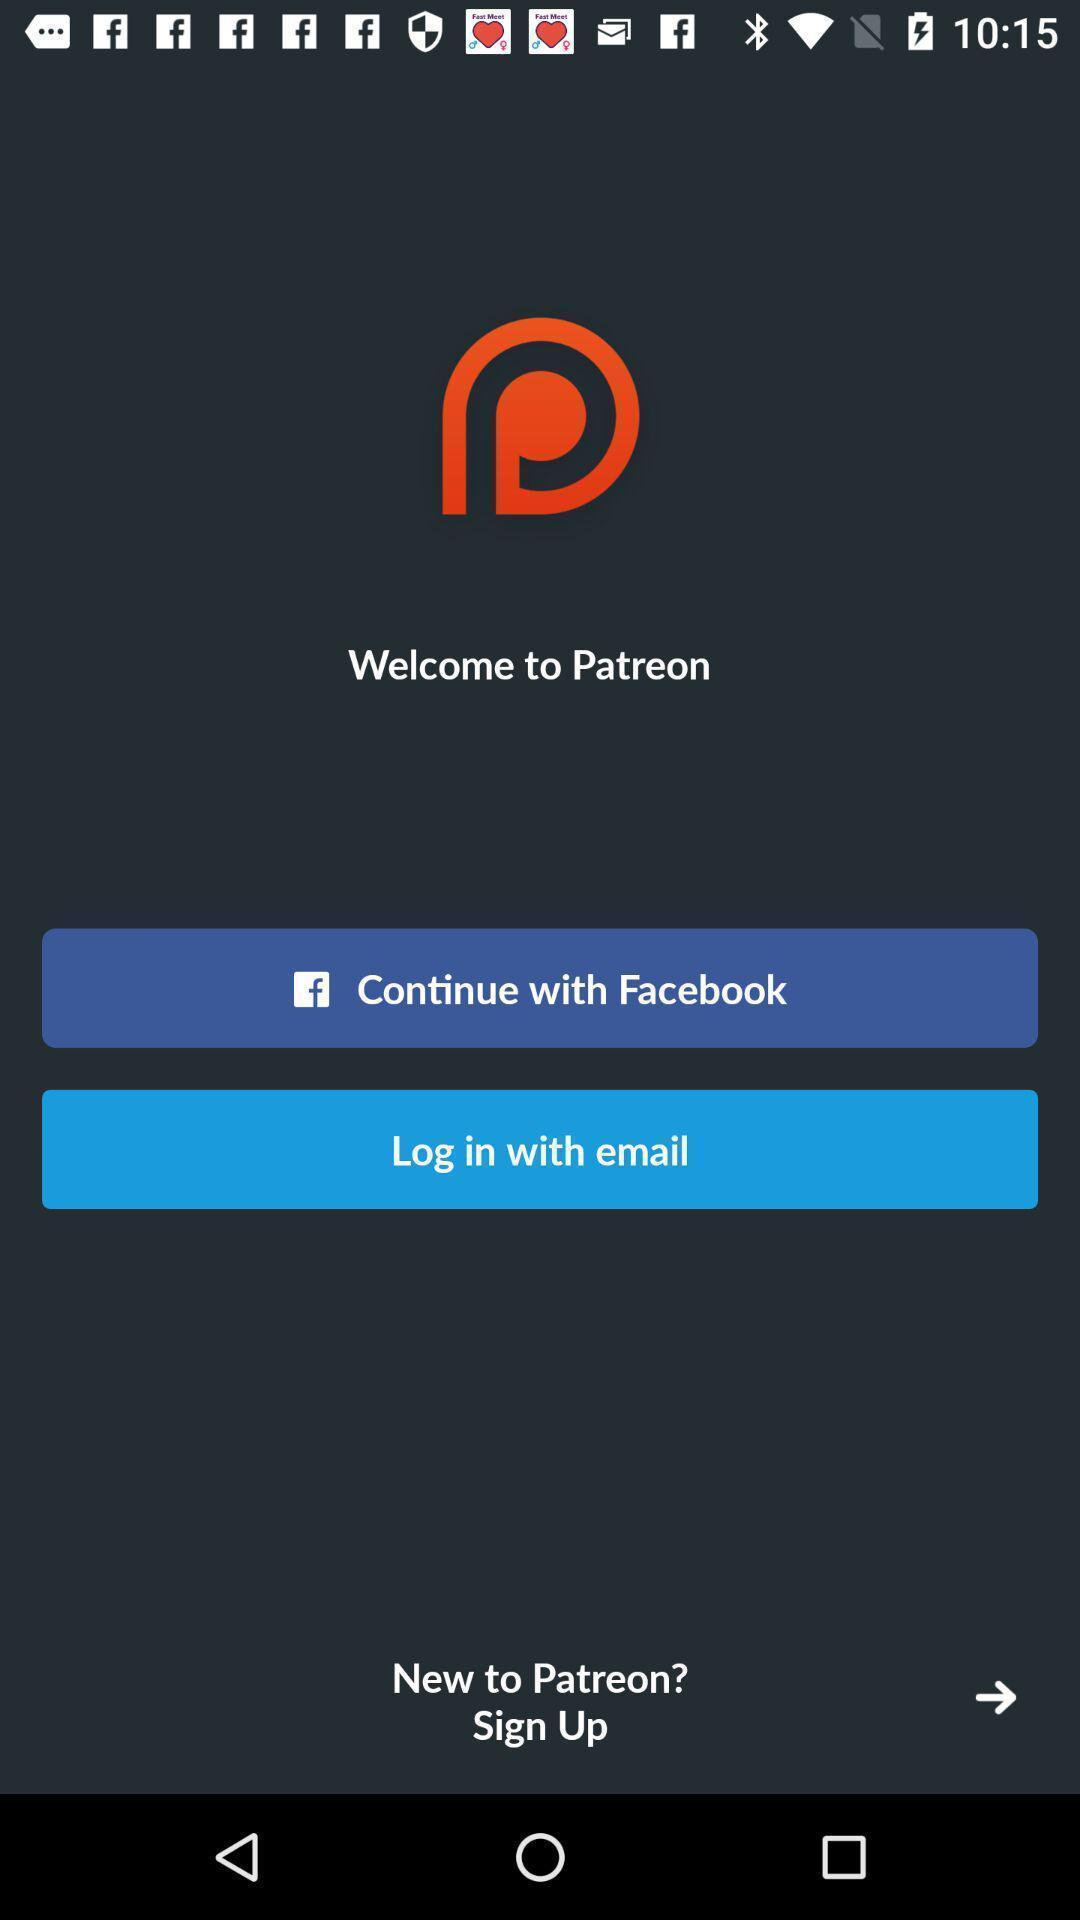Provide a description of this screenshot. Screen displaying the login page. 